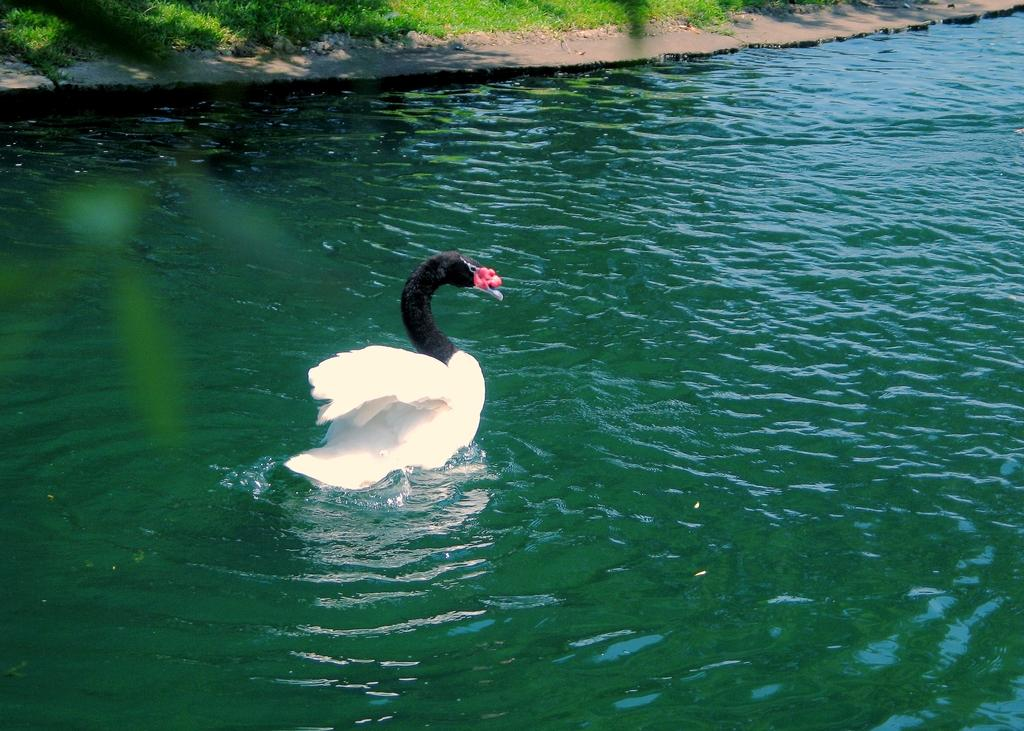What animal can be seen in the image? There is a swan in the image. What is the swan doing in the image? The swan is swimming in the water. What type of terrain is visible in the image? There is a ground covered with sand in the image. How many stamps does the swan have on its wings in the image? There are no stamps present on the swan's wings in the image. 